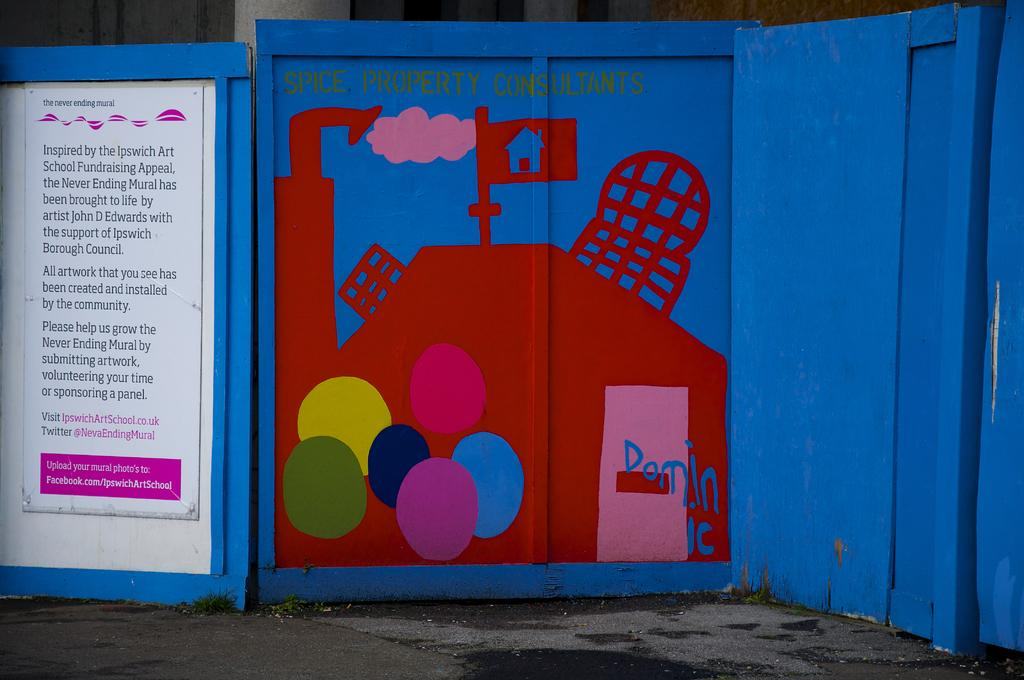Provide a one-sentence caption for the provided image. A picture in red on blue with Spice Property Consultations written on it. 